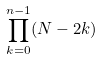<formula> <loc_0><loc_0><loc_500><loc_500>\prod _ { k = 0 } ^ { n - 1 } ( N - 2 k )</formula> 